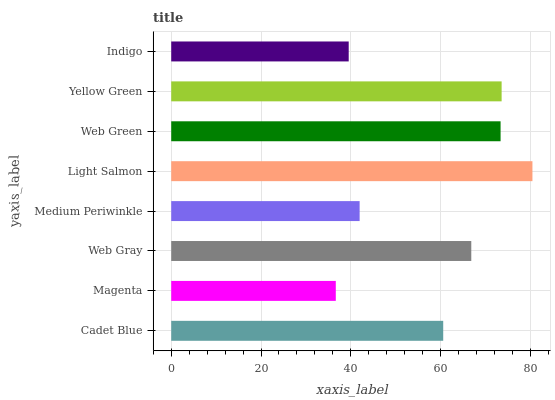Is Magenta the minimum?
Answer yes or no. Yes. Is Light Salmon the maximum?
Answer yes or no. Yes. Is Web Gray the minimum?
Answer yes or no. No. Is Web Gray the maximum?
Answer yes or no. No. Is Web Gray greater than Magenta?
Answer yes or no. Yes. Is Magenta less than Web Gray?
Answer yes or no. Yes. Is Magenta greater than Web Gray?
Answer yes or no. No. Is Web Gray less than Magenta?
Answer yes or no. No. Is Web Gray the high median?
Answer yes or no. Yes. Is Cadet Blue the low median?
Answer yes or no. Yes. Is Cadet Blue the high median?
Answer yes or no. No. Is Indigo the low median?
Answer yes or no. No. 